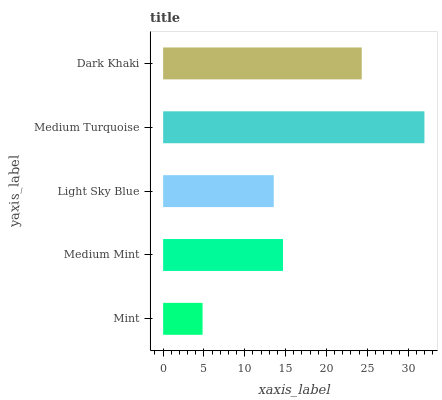Is Mint the minimum?
Answer yes or no. Yes. Is Medium Turquoise the maximum?
Answer yes or no. Yes. Is Medium Mint the minimum?
Answer yes or no. No. Is Medium Mint the maximum?
Answer yes or no. No. Is Medium Mint greater than Mint?
Answer yes or no. Yes. Is Mint less than Medium Mint?
Answer yes or no. Yes. Is Mint greater than Medium Mint?
Answer yes or no. No. Is Medium Mint less than Mint?
Answer yes or no. No. Is Medium Mint the high median?
Answer yes or no. Yes. Is Medium Mint the low median?
Answer yes or no. Yes. Is Mint the high median?
Answer yes or no. No. Is Medium Turquoise the low median?
Answer yes or no. No. 